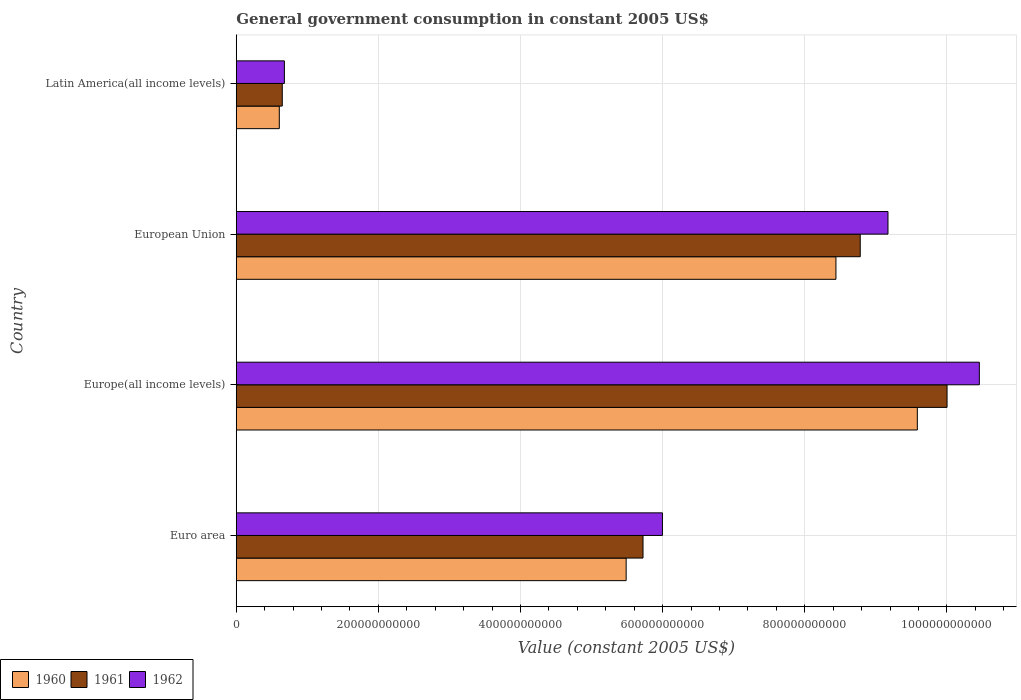How many different coloured bars are there?
Offer a very short reply. 3. How many groups of bars are there?
Ensure brevity in your answer.  4. Are the number of bars per tick equal to the number of legend labels?
Offer a terse response. Yes. Are the number of bars on each tick of the Y-axis equal?
Ensure brevity in your answer.  Yes. How many bars are there on the 3rd tick from the top?
Make the answer very short. 3. How many bars are there on the 4th tick from the bottom?
Make the answer very short. 3. What is the label of the 1st group of bars from the top?
Your answer should be compact. Latin America(all income levels). In how many cases, is the number of bars for a given country not equal to the number of legend labels?
Offer a very short reply. 0. What is the government conusmption in 1961 in European Union?
Make the answer very short. 8.78e+11. Across all countries, what is the maximum government conusmption in 1962?
Offer a very short reply. 1.05e+12. Across all countries, what is the minimum government conusmption in 1962?
Your answer should be very brief. 6.77e+1. In which country was the government conusmption in 1960 maximum?
Make the answer very short. Europe(all income levels). In which country was the government conusmption in 1960 minimum?
Provide a short and direct response. Latin America(all income levels). What is the total government conusmption in 1962 in the graph?
Your answer should be very brief. 2.63e+12. What is the difference between the government conusmption in 1961 in Europe(all income levels) and that in Latin America(all income levels)?
Your answer should be very brief. 9.35e+11. What is the difference between the government conusmption in 1962 in European Union and the government conusmption in 1960 in Latin America(all income levels)?
Make the answer very short. 8.56e+11. What is the average government conusmption in 1960 per country?
Your answer should be compact. 6.03e+11. What is the difference between the government conusmption in 1961 and government conusmption in 1962 in European Union?
Your response must be concise. -3.90e+1. What is the ratio of the government conusmption in 1960 in European Union to that in Latin America(all income levels)?
Keep it short and to the point. 13.93. Is the difference between the government conusmption in 1961 in Europe(all income levels) and European Union greater than the difference between the government conusmption in 1962 in Europe(all income levels) and European Union?
Ensure brevity in your answer.  No. What is the difference between the highest and the second highest government conusmption in 1961?
Give a very brief answer. 1.22e+11. What is the difference between the highest and the lowest government conusmption in 1960?
Your answer should be very brief. 8.98e+11. In how many countries, is the government conusmption in 1962 greater than the average government conusmption in 1962 taken over all countries?
Keep it short and to the point. 2. What does the 2nd bar from the top in Europe(all income levels) represents?
Ensure brevity in your answer.  1961. What does the 2nd bar from the bottom in Euro area represents?
Offer a terse response. 1961. Is it the case that in every country, the sum of the government conusmption in 1960 and government conusmption in 1961 is greater than the government conusmption in 1962?
Your answer should be compact. Yes. How many bars are there?
Offer a very short reply. 12. What is the difference between two consecutive major ticks on the X-axis?
Make the answer very short. 2.00e+11. Does the graph contain any zero values?
Keep it short and to the point. No. Does the graph contain grids?
Your answer should be compact. Yes. How many legend labels are there?
Offer a very short reply. 3. What is the title of the graph?
Keep it short and to the point. General government consumption in constant 2005 US$. What is the label or title of the X-axis?
Offer a very short reply. Value (constant 2005 US$). What is the Value (constant 2005 US$) in 1960 in Euro area?
Your answer should be very brief. 5.49e+11. What is the Value (constant 2005 US$) of 1961 in Euro area?
Give a very brief answer. 5.72e+11. What is the Value (constant 2005 US$) of 1962 in Euro area?
Give a very brief answer. 6.00e+11. What is the Value (constant 2005 US$) of 1960 in Europe(all income levels)?
Provide a succinct answer. 9.58e+11. What is the Value (constant 2005 US$) of 1961 in Europe(all income levels)?
Your response must be concise. 1.00e+12. What is the Value (constant 2005 US$) of 1962 in Europe(all income levels)?
Your response must be concise. 1.05e+12. What is the Value (constant 2005 US$) of 1960 in European Union?
Make the answer very short. 8.44e+11. What is the Value (constant 2005 US$) in 1961 in European Union?
Offer a terse response. 8.78e+11. What is the Value (constant 2005 US$) of 1962 in European Union?
Offer a very short reply. 9.17e+11. What is the Value (constant 2005 US$) in 1960 in Latin America(all income levels)?
Keep it short and to the point. 6.06e+1. What is the Value (constant 2005 US$) of 1961 in Latin America(all income levels)?
Your response must be concise. 6.47e+1. What is the Value (constant 2005 US$) in 1962 in Latin America(all income levels)?
Offer a terse response. 6.77e+1. Across all countries, what is the maximum Value (constant 2005 US$) of 1960?
Ensure brevity in your answer.  9.58e+11. Across all countries, what is the maximum Value (constant 2005 US$) of 1961?
Keep it short and to the point. 1.00e+12. Across all countries, what is the maximum Value (constant 2005 US$) of 1962?
Offer a terse response. 1.05e+12. Across all countries, what is the minimum Value (constant 2005 US$) of 1960?
Keep it short and to the point. 6.06e+1. Across all countries, what is the minimum Value (constant 2005 US$) in 1961?
Offer a very short reply. 6.47e+1. Across all countries, what is the minimum Value (constant 2005 US$) in 1962?
Ensure brevity in your answer.  6.77e+1. What is the total Value (constant 2005 US$) of 1960 in the graph?
Offer a terse response. 2.41e+12. What is the total Value (constant 2005 US$) of 1961 in the graph?
Your answer should be compact. 2.52e+12. What is the total Value (constant 2005 US$) in 1962 in the graph?
Your answer should be very brief. 2.63e+12. What is the difference between the Value (constant 2005 US$) of 1960 in Euro area and that in Europe(all income levels)?
Keep it short and to the point. -4.10e+11. What is the difference between the Value (constant 2005 US$) in 1961 in Euro area and that in Europe(all income levels)?
Keep it short and to the point. -4.28e+11. What is the difference between the Value (constant 2005 US$) of 1962 in Euro area and that in Europe(all income levels)?
Provide a succinct answer. -4.46e+11. What is the difference between the Value (constant 2005 US$) of 1960 in Euro area and that in European Union?
Provide a succinct answer. -2.95e+11. What is the difference between the Value (constant 2005 US$) of 1961 in Euro area and that in European Union?
Keep it short and to the point. -3.06e+11. What is the difference between the Value (constant 2005 US$) of 1962 in Euro area and that in European Union?
Your answer should be compact. -3.17e+11. What is the difference between the Value (constant 2005 US$) of 1960 in Euro area and that in Latin America(all income levels)?
Your answer should be very brief. 4.88e+11. What is the difference between the Value (constant 2005 US$) of 1961 in Euro area and that in Latin America(all income levels)?
Give a very brief answer. 5.08e+11. What is the difference between the Value (constant 2005 US$) of 1962 in Euro area and that in Latin America(all income levels)?
Provide a short and direct response. 5.32e+11. What is the difference between the Value (constant 2005 US$) in 1960 in Europe(all income levels) and that in European Union?
Provide a succinct answer. 1.15e+11. What is the difference between the Value (constant 2005 US$) of 1961 in Europe(all income levels) and that in European Union?
Make the answer very short. 1.22e+11. What is the difference between the Value (constant 2005 US$) of 1962 in Europe(all income levels) and that in European Union?
Offer a terse response. 1.29e+11. What is the difference between the Value (constant 2005 US$) in 1960 in Europe(all income levels) and that in Latin America(all income levels)?
Give a very brief answer. 8.98e+11. What is the difference between the Value (constant 2005 US$) of 1961 in Europe(all income levels) and that in Latin America(all income levels)?
Your answer should be very brief. 9.35e+11. What is the difference between the Value (constant 2005 US$) of 1962 in Europe(all income levels) and that in Latin America(all income levels)?
Make the answer very short. 9.78e+11. What is the difference between the Value (constant 2005 US$) of 1960 in European Union and that in Latin America(all income levels)?
Provide a succinct answer. 7.83e+11. What is the difference between the Value (constant 2005 US$) in 1961 in European Union and that in Latin America(all income levels)?
Your response must be concise. 8.13e+11. What is the difference between the Value (constant 2005 US$) of 1962 in European Union and that in Latin America(all income levels)?
Provide a short and direct response. 8.49e+11. What is the difference between the Value (constant 2005 US$) in 1960 in Euro area and the Value (constant 2005 US$) in 1961 in Europe(all income levels)?
Provide a succinct answer. -4.52e+11. What is the difference between the Value (constant 2005 US$) in 1960 in Euro area and the Value (constant 2005 US$) in 1962 in Europe(all income levels)?
Your answer should be very brief. -4.97e+11. What is the difference between the Value (constant 2005 US$) in 1961 in Euro area and the Value (constant 2005 US$) in 1962 in Europe(all income levels)?
Provide a short and direct response. -4.73e+11. What is the difference between the Value (constant 2005 US$) in 1960 in Euro area and the Value (constant 2005 US$) in 1961 in European Union?
Your response must be concise. -3.29e+11. What is the difference between the Value (constant 2005 US$) of 1960 in Euro area and the Value (constant 2005 US$) of 1962 in European Union?
Provide a succinct answer. -3.68e+11. What is the difference between the Value (constant 2005 US$) of 1961 in Euro area and the Value (constant 2005 US$) of 1962 in European Union?
Make the answer very short. -3.45e+11. What is the difference between the Value (constant 2005 US$) in 1960 in Euro area and the Value (constant 2005 US$) in 1961 in Latin America(all income levels)?
Offer a terse response. 4.84e+11. What is the difference between the Value (constant 2005 US$) in 1960 in Euro area and the Value (constant 2005 US$) in 1962 in Latin America(all income levels)?
Your answer should be very brief. 4.81e+11. What is the difference between the Value (constant 2005 US$) in 1961 in Euro area and the Value (constant 2005 US$) in 1962 in Latin America(all income levels)?
Provide a short and direct response. 5.05e+11. What is the difference between the Value (constant 2005 US$) in 1960 in Europe(all income levels) and the Value (constant 2005 US$) in 1961 in European Union?
Ensure brevity in your answer.  8.03e+1. What is the difference between the Value (constant 2005 US$) in 1960 in Europe(all income levels) and the Value (constant 2005 US$) in 1962 in European Union?
Offer a terse response. 4.13e+1. What is the difference between the Value (constant 2005 US$) in 1961 in Europe(all income levels) and the Value (constant 2005 US$) in 1962 in European Union?
Offer a terse response. 8.31e+1. What is the difference between the Value (constant 2005 US$) of 1960 in Europe(all income levels) and the Value (constant 2005 US$) of 1961 in Latin America(all income levels)?
Ensure brevity in your answer.  8.94e+11. What is the difference between the Value (constant 2005 US$) of 1960 in Europe(all income levels) and the Value (constant 2005 US$) of 1962 in Latin America(all income levels)?
Provide a short and direct response. 8.91e+11. What is the difference between the Value (constant 2005 US$) of 1961 in Europe(all income levels) and the Value (constant 2005 US$) of 1962 in Latin America(all income levels)?
Provide a succinct answer. 9.32e+11. What is the difference between the Value (constant 2005 US$) in 1960 in European Union and the Value (constant 2005 US$) in 1961 in Latin America(all income levels)?
Provide a short and direct response. 7.79e+11. What is the difference between the Value (constant 2005 US$) in 1960 in European Union and the Value (constant 2005 US$) in 1962 in Latin America(all income levels)?
Offer a terse response. 7.76e+11. What is the difference between the Value (constant 2005 US$) in 1961 in European Union and the Value (constant 2005 US$) in 1962 in Latin America(all income levels)?
Offer a terse response. 8.10e+11. What is the average Value (constant 2005 US$) in 1960 per country?
Provide a short and direct response. 6.03e+11. What is the average Value (constant 2005 US$) of 1961 per country?
Ensure brevity in your answer.  6.29e+11. What is the average Value (constant 2005 US$) in 1962 per country?
Your response must be concise. 6.58e+11. What is the difference between the Value (constant 2005 US$) in 1960 and Value (constant 2005 US$) in 1961 in Euro area?
Give a very brief answer. -2.37e+1. What is the difference between the Value (constant 2005 US$) of 1960 and Value (constant 2005 US$) of 1962 in Euro area?
Ensure brevity in your answer.  -5.10e+1. What is the difference between the Value (constant 2005 US$) of 1961 and Value (constant 2005 US$) of 1962 in Euro area?
Ensure brevity in your answer.  -2.73e+1. What is the difference between the Value (constant 2005 US$) of 1960 and Value (constant 2005 US$) of 1961 in Europe(all income levels)?
Give a very brief answer. -4.18e+1. What is the difference between the Value (constant 2005 US$) of 1960 and Value (constant 2005 US$) of 1962 in Europe(all income levels)?
Keep it short and to the point. -8.73e+1. What is the difference between the Value (constant 2005 US$) in 1961 and Value (constant 2005 US$) in 1962 in Europe(all income levels)?
Ensure brevity in your answer.  -4.54e+1. What is the difference between the Value (constant 2005 US$) of 1960 and Value (constant 2005 US$) of 1961 in European Union?
Provide a succinct answer. -3.42e+1. What is the difference between the Value (constant 2005 US$) in 1960 and Value (constant 2005 US$) in 1962 in European Union?
Give a very brief answer. -7.32e+1. What is the difference between the Value (constant 2005 US$) in 1961 and Value (constant 2005 US$) in 1962 in European Union?
Keep it short and to the point. -3.90e+1. What is the difference between the Value (constant 2005 US$) in 1960 and Value (constant 2005 US$) in 1961 in Latin America(all income levels)?
Provide a succinct answer. -4.16e+09. What is the difference between the Value (constant 2005 US$) of 1960 and Value (constant 2005 US$) of 1962 in Latin America(all income levels)?
Your answer should be compact. -7.17e+09. What is the difference between the Value (constant 2005 US$) in 1961 and Value (constant 2005 US$) in 1962 in Latin America(all income levels)?
Make the answer very short. -3.01e+09. What is the ratio of the Value (constant 2005 US$) in 1960 in Euro area to that in Europe(all income levels)?
Your response must be concise. 0.57. What is the ratio of the Value (constant 2005 US$) of 1961 in Euro area to that in Europe(all income levels)?
Ensure brevity in your answer.  0.57. What is the ratio of the Value (constant 2005 US$) of 1962 in Euro area to that in Europe(all income levels)?
Your answer should be very brief. 0.57. What is the ratio of the Value (constant 2005 US$) of 1960 in Euro area to that in European Union?
Provide a succinct answer. 0.65. What is the ratio of the Value (constant 2005 US$) of 1961 in Euro area to that in European Union?
Offer a terse response. 0.65. What is the ratio of the Value (constant 2005 US$) of 1962 in Euro area to that in European Union?
Your answer should be compact. 0.65. What is the ratio of the Value (constant 2005 US$) of 1960 in Euro area to that in Latin America(all income levels)?
Ensure brevity in your answer.  9.06. What is the ratio of the Value (constant 2005 US$) of 1961 in Euro area to that in Latin America(all income levels)?
Provide a succinct answer. 8.84. What is the ratio of the Value (constant 2005 US$) of 1962 in Euro area to that in Latin America(all income levels)?
Make the answer very short. 8.85. What is the ratio of the Value (constant 2005 US$) of 1960 in Europe(all income levels) to that in European Union?
Provide a succinct answer. 1.14. What is the ratio of the Value (constant 2005 US$) in 1961 in Europe(all income levels) to that in European Union?
Ensure brevity in your answer.  1.14. What is the ratio of the Value (constant 2005 US$) in 1962 in Europe(all income levels) to that in European Union?
Keep it short and to the point. 1.14. What is the ratio of the Value (constant 2005 US$) of 1960 in Europe(all income levels) to that in Latin America(all income levels)?
Your response must be concise. 15.82. What is the ratio of the Value (constant 2005 US$) in 1961 in Europe(all income levels) to that in Latin America(all income levels)?
Offer a terse response. 15.45. What is the ratio of the Value (constant 2005 US$) of 1962 in Europe(all income levels) to that in Latin America(all income levels)?
Give a very brief answer. 15.43. What is the ratio of the Value (constant 2005 US$) of 1960 in European Union to that in Latin America(all income levels)?
Ensure brevity in your answer.  13.93. What is the ratio of the Value (constant 2005 US$) in 1961 in European Union to that in Latin America(all income levels)?
Your answer should be compact. 13.56. What is the ratio of the Value (constant 2005 US$) in 1962 in European Union to that in Latin America(all income levels)?
Keep it short and to the point. 13.54. What is the difference between the highest and the second highest Value (constant 2005 US$) in 1960?
Give a very brief answer. 1.15e+11. What is the difference between the highest and the second highest Value (constant 2005 US$) of 1961?
Your response must be concise. 1.22e+11. What is the difference between the highest and the second highest Value (constant 2005 US$) in 1962?
Keep it short and to the point. 1.29e+11. What is the difference between the highest and the lowest Value (constant 2005 US$) in 1960?
Make the answer very short. 8.98e+11. What is the difference between the highest and the lowest Value (constant 2005 US$) of 1961?
Make the answer very short. 9.35e+11. What is the difference between the highest and the lowest Value (constant 2005 US$) of 1962?
Ensure brevity in your answer.  9.78e+11. 